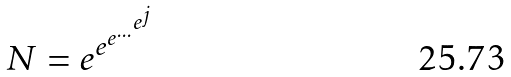<formula> <loc_0><loc_0><loc_500><loc_500>N = e ^ { e ^ { e ^ { \dots ^ { e ^ { j } } } } }</formula> 